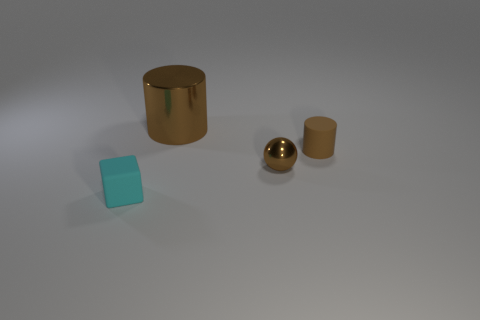What shape is the tiny thing that is the same color as the matte cylinder?
Give a very brief answer. Sphere. What is the shape of the tiny cyan object?
Make the answer very short. Cube. Do the large metallic cylinder and the metallic sphere have the same color?
Keep it short and to the point. Yes. How many things are either tiny things behind the small block or tiny cubes?
Keep it short and to the point. 3. There is a cyan object that is made of the same material as the small cylinder; what is its size?
Give a very brief answer. Small. Is the number of tiny cyan cubes that are in front of the small brown metallic ball greater than the number of big gray spheres?
Keep it short and to the point. Yes. Is the shape of the large brown object the same as the matte object to the right of the large thing?
Provide a short and direct response. Yes. What number of big things are either rubber blocks or matte spheres?
Offer a terse response. 0. The rubber cylinder that is the same color as the ball is what size?
Provide a succinct answer. Small. There is a rubber thing that is behind the rubber object in front of the tiny rubber cylinder; what is its color?
Provide a short and direct response. Brown. 